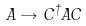<formula> <loc_0><loc_0><loc_500><loc_500>A \rightarrow C ^ { \dagger } A C</formula> 